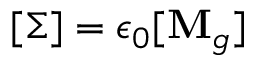Convert formula to latex. <formula><loc_0><loc_0><loc_500><loc_500>[ \Sigma ] = \epsilon _ { 0 } [ M _ { g } ]</formula> 